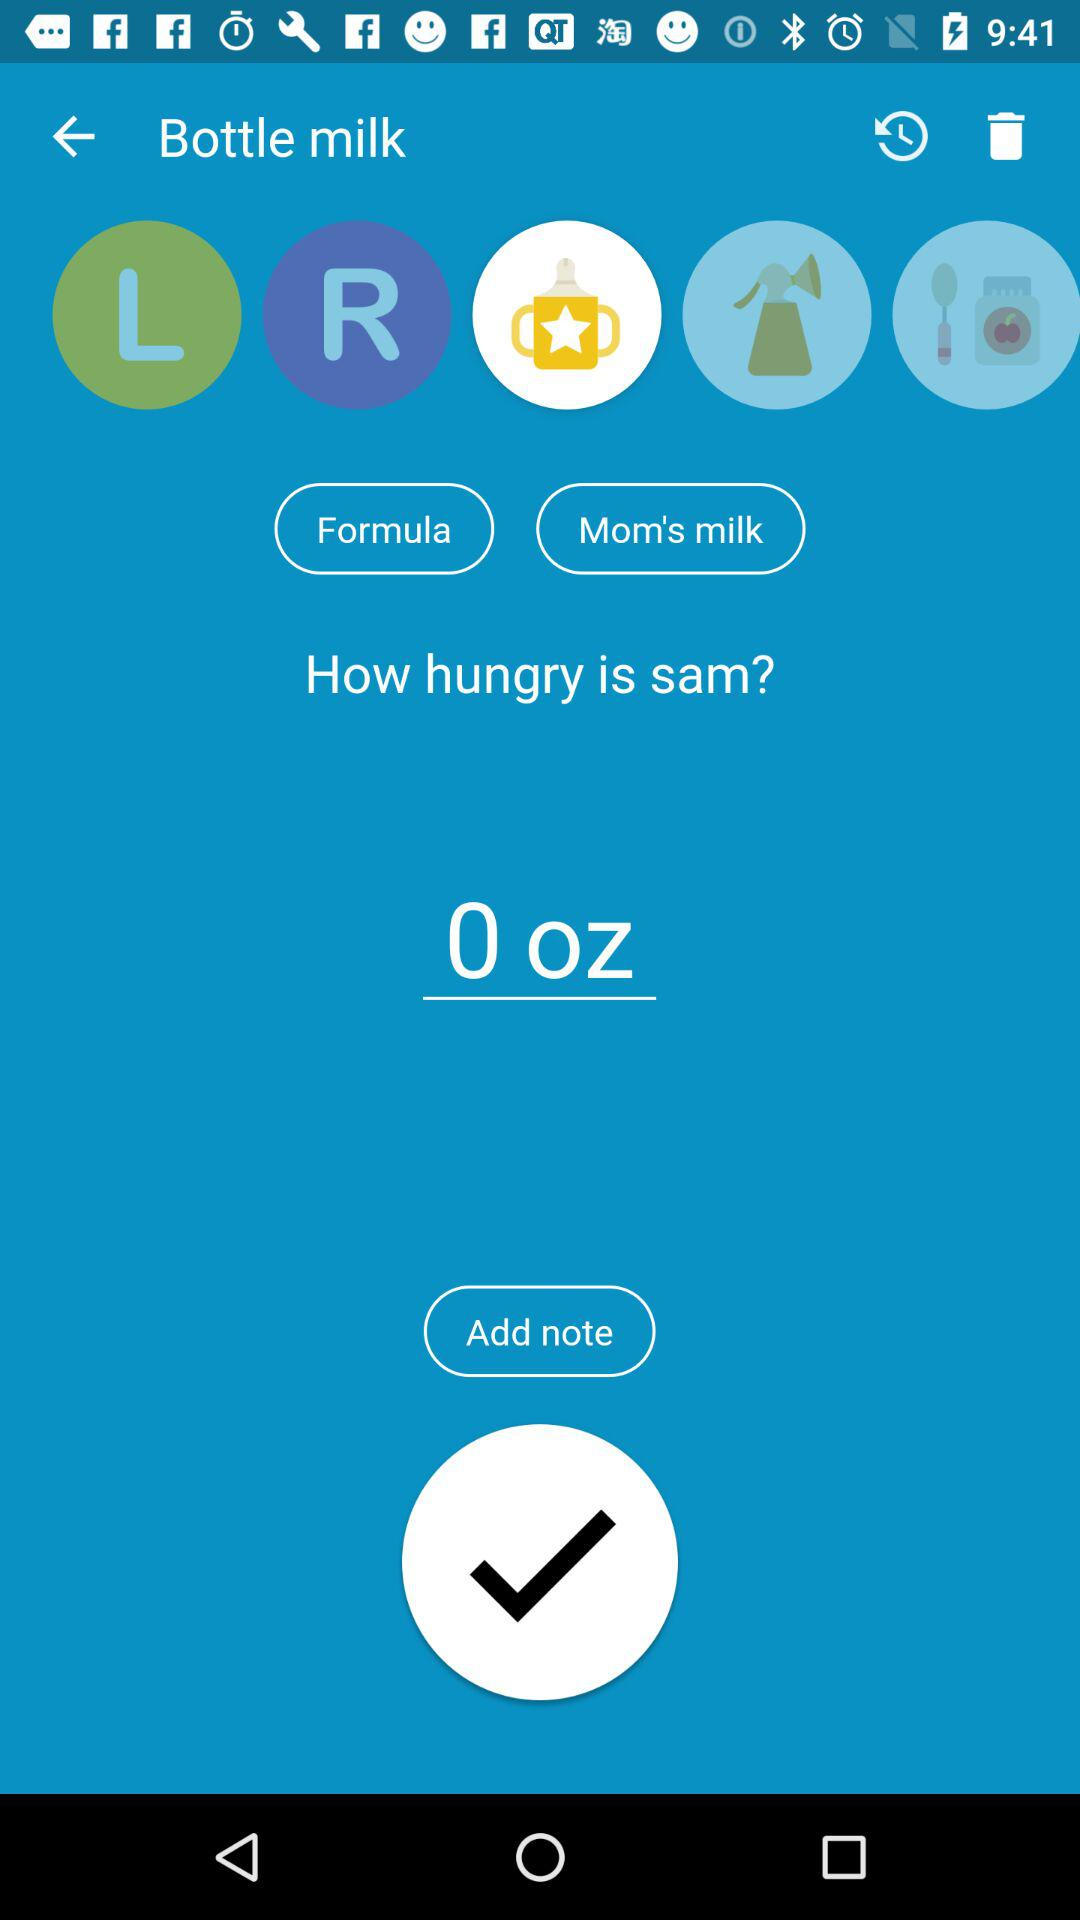How many options are there to choose from for how Sam is fed?
Answer the question using a single word or phrase. 2 